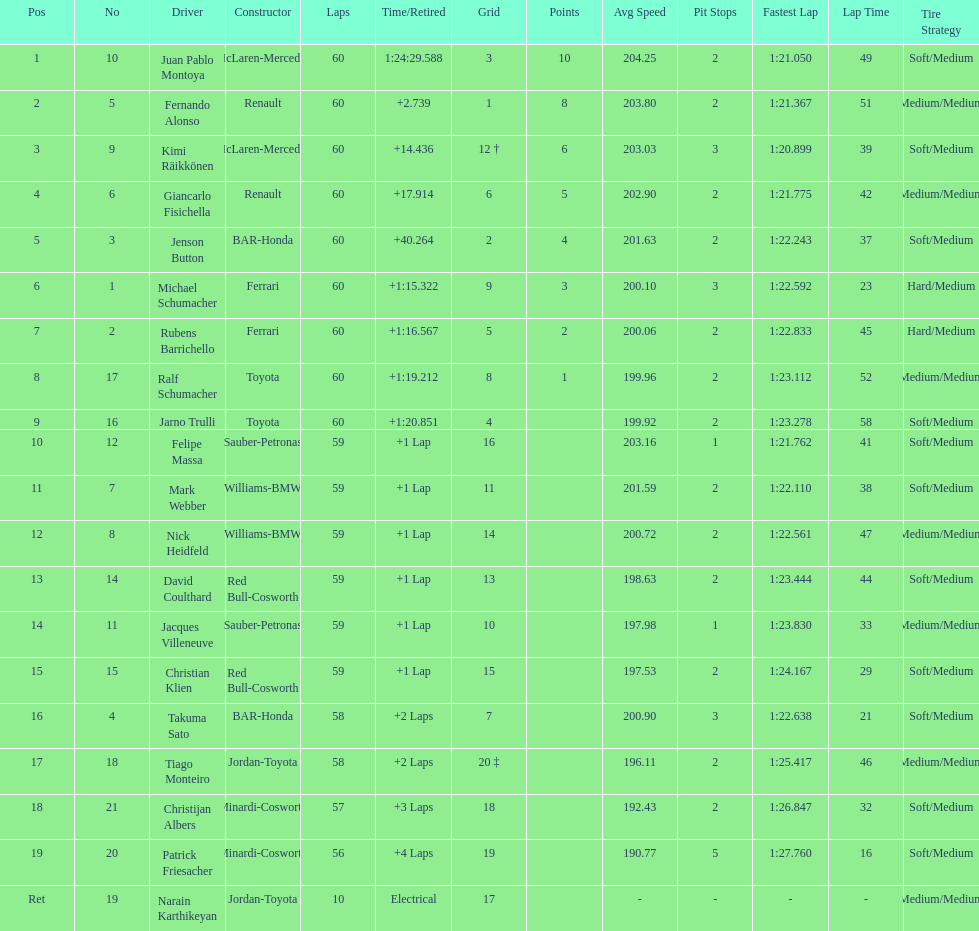Which driver came after giancarlo fisichella? Jenson Button. 